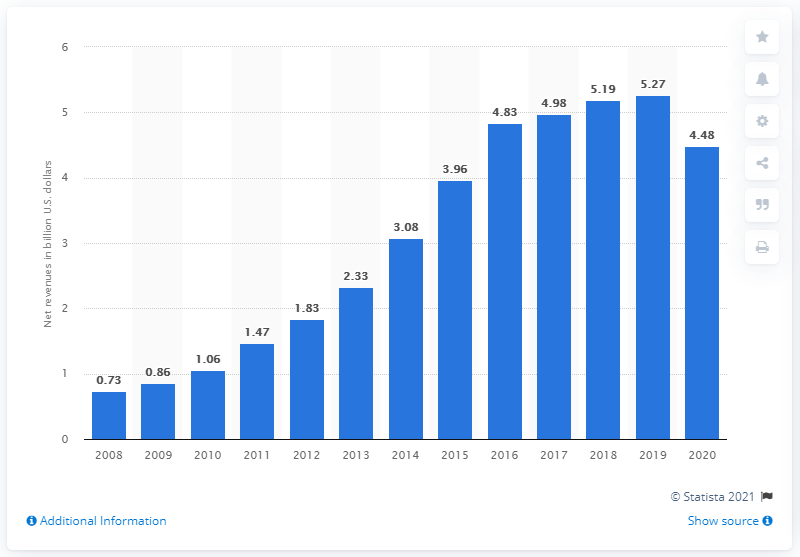Point out several critical features in this image. In 2009, Under Armour generated approximately 4.48 billion US dollars in revenue in the United States. In 2020, Under Armour's global net revenues were 4.48 billion U.S. dollars. 